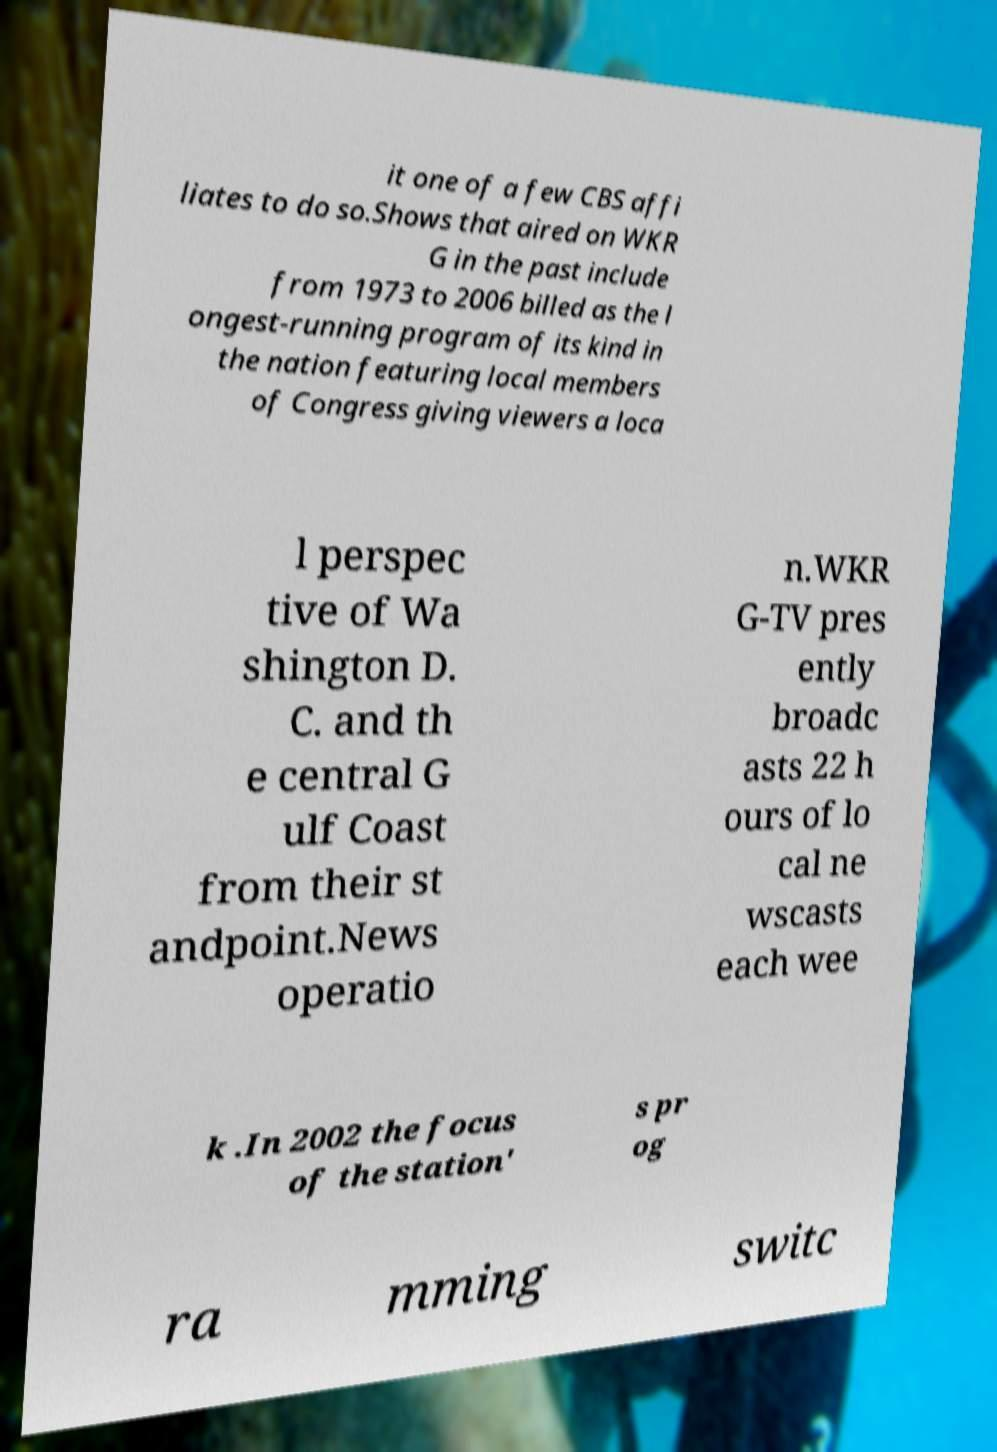There's text embedded in this image that I need extracted. Can you transcribe it verbatim? it one of a few CBS affi liates to do so.Shows that aired on WKR G in the past include from 1973 to 2006 billed as the l ongest-running program of its kind in the nation featuring local members of Congress giving viewers a loca l perspec tive of Wa shington D. C. and th e central G ulf Coast from their st andpoint.News operatio n.WKR G-TV pres ently broadc asts 22 h ours of lo cal ne wscasts each wee k .In 2002 the focus of the station' s pr og ra mming switc 